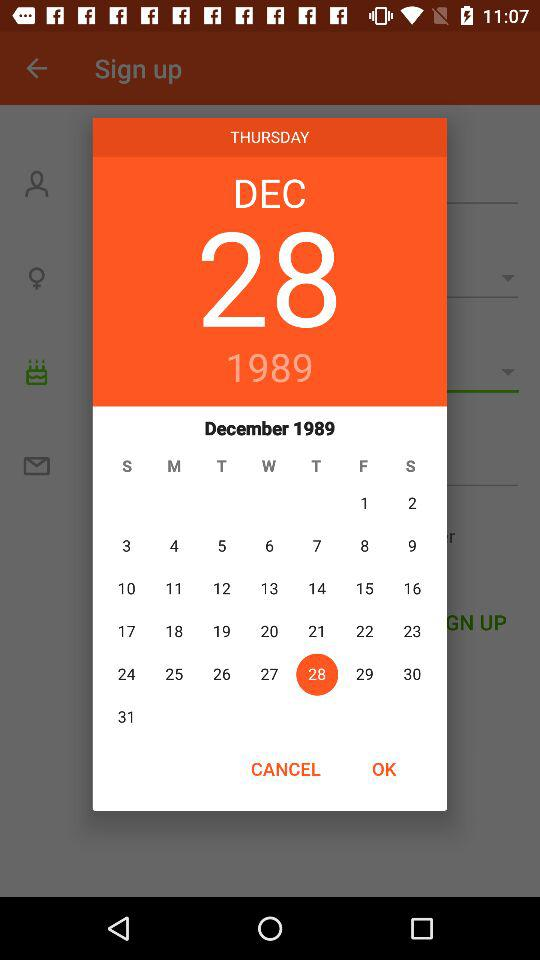What's the mentioned month and year? The month and year mentioned are December 1989. 